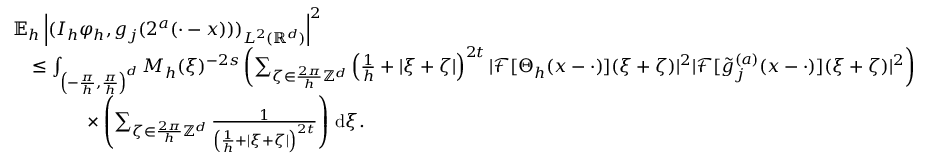Convert formula to latex. <formula><loc_0><loc_0><loc_500><loc_500>\begin{array} { r l } & { \mathbb { E } _ { h } \left | ( I _ { h } \varphi _ { h } , g _ { j } ( 2 ^ { a } ( \cdot - x ) ) ) _ { L ^ { 2 } ( \mathbb { R } ^ { d } ) } \right | ^ { 2 } } \\ & { \quad \leq \int _ { \left ( - \frac { \pi } { h } , \frac { \pi } { h } \right ) ^ { d } } M _ { h } ( \xi ) ^ { - 2 s } \left ( \sum _ { \zeta \in \frac { 2 \pi } { h } \mathbb { Z } ^ { d } } \left ( \frac { 1 } { h } + | \xi + \zeta | \right ) ^ { 2 t } | \mathcal { F } [ \Theta _ { h } ( x - \cdot ) ] ( \xi + \zeta ) | ^ { 2 } | \mathcal { F } [ \tilde { g } _ { j } ^ { ( a ) } ( x - \cdot ) ] ( \xi + \zeta ) | ^ { 2 } \right ) } \\ & { \quad \times \left ( \sum _ { \zeta \in \frac { 2 \pi } { h } \mathbb { Z } ^ { d } } \frac { 1 } { \left ( \frac { 1 } { h } + | \xi + \zeta | \right ) ^ { 2 t } } \right ) \, d \xi . } \end{array}</formula> 